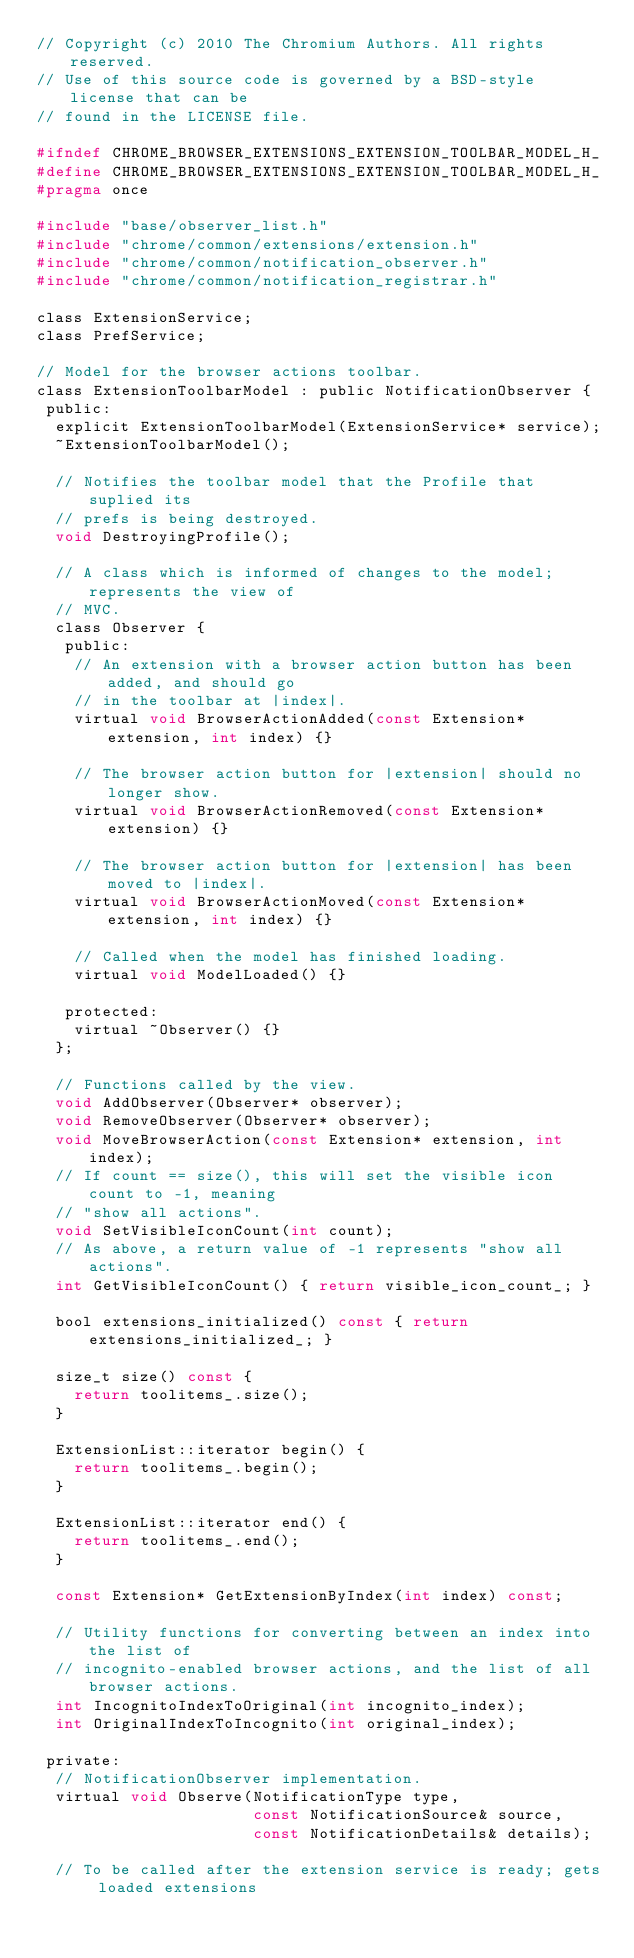Convert code to text. <code><loc_0><loc_0><loc_500><loc_500><_C_>// Copyright (c) 2010 The Chromium Authors. All rights reserved.
// Use of this source code is governed by a BSD-style license that can be
// found in the LICENSE file.

#ifndef CHROME_BROWSER_EXTENSIONS_EXTENSION_TOOLBAR_MODEL_H_
#define CHROME_BROWSER_EXTENSIONS_EXTENSION_TOOLBAR_MODEL_H_
#pragma once

#include "base/observer_list.h"
#include "chrome/common/extensions/extension.h"
#include "chrome/common/notification_observer.h"
#include "chrome/common/notification_registrar.h"

class ExtensionService;
class PrefService;

// Model for the browser actions toolbar.
class ExtensionToolbarModel : public NotificationObserver {
 public:
  explicit ExtensionToolbarModel(ExtensionService* service);
  ~ExtensionToolbarModel();

  // Notifies the toolbar model that the Profile that suplied its
  // prefs is being destroyed.
  void DestroyingProfile();

  // A class which is informed of changes to the model; represents the view of
  // MVC.
  class Observer {
   public:
    // An extension with a browser action button has been added, and should go
    // in the toolbar at |index|.
    virtual void BrowserActionAdded(const Extension* extension, int index) {}

    // The browser action button for |extension| should no longer show.
    virtual void BrowserActionRemoved(const Extension* extension) {}

    // The browser action button for |extension| has been moved to |index|.
    virtual void BrowserActionMoved(const Extension* extension, int index) {}

    // Called when the model has finished loading.
    virtual void ModelLoaded() {}

   protected:
    virtual ~Observer() {}
  };

  // Functions called by the view.
  void AddObserver(Observer* observer);
  void RemoveObserver(Observer* observer);
  void MoveBrowserAction(const Extension* extension, int index);
  // If count == size(), this will set the visible icon count to -1, meaning
  // "show all actions".
  void SetVisibleIconCount(int count);
  // As above, a return value of -1 represents "show all actions".
  int GetVisibleIconCount() { return visible_icon_count_; }

  bool extensions_initialized() const { return extensions_initialized_; }

  size_t size() const {
    return toolitems_.size();
  }

  ExtensionList::iterator begin() {
    return toolitems_.begin();
  }

  ExtensionList::iterator end() {
    return toolitems_.end();
  }

  const Extension* GetExtensionByIndex(int index) const;

  // Utility functions for converting between an index into the list of
  // incognito-enabled browser actions, and the list of all browser actions.
  int IncognitoIndexToOriginal(int incognito_index);
  int OriginalIndexToIncognito(int original_index);

 private:
  // NotificationObserver implementation.
  virtual void Observe(NotificationType type,
                       const NotificationSource& source,
                       const NotificationDetails& details);

  // To be called after the extension service is ready; gets loaded extensions</code> 